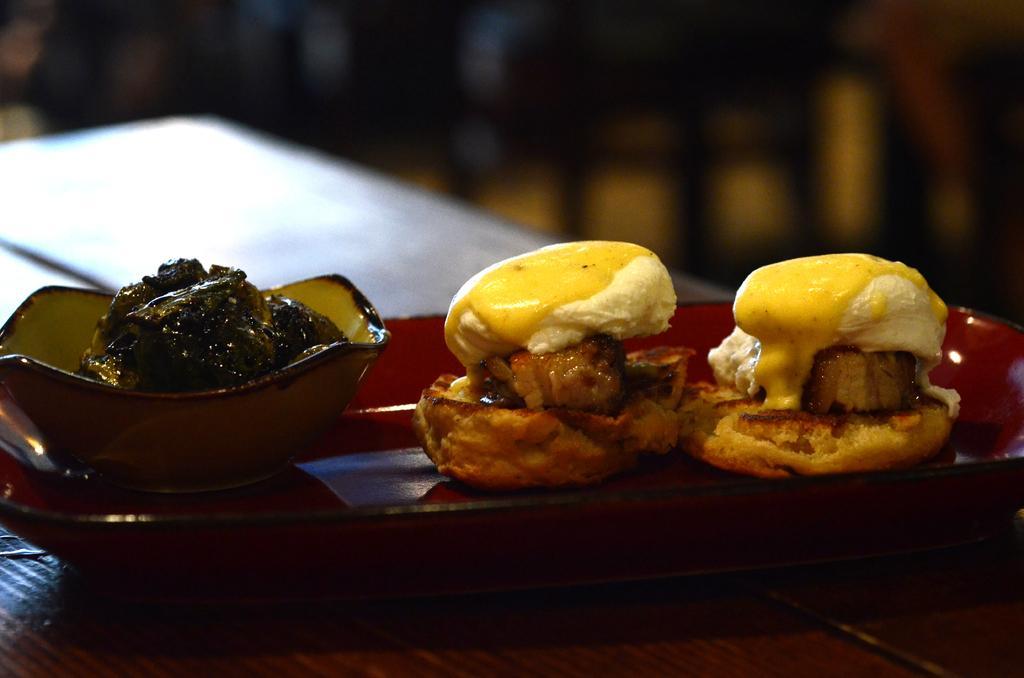Could you give a brief overview of what you see in this image? In this image we can see food item which is in white, brown and yellow color is kept on a red color plate. 